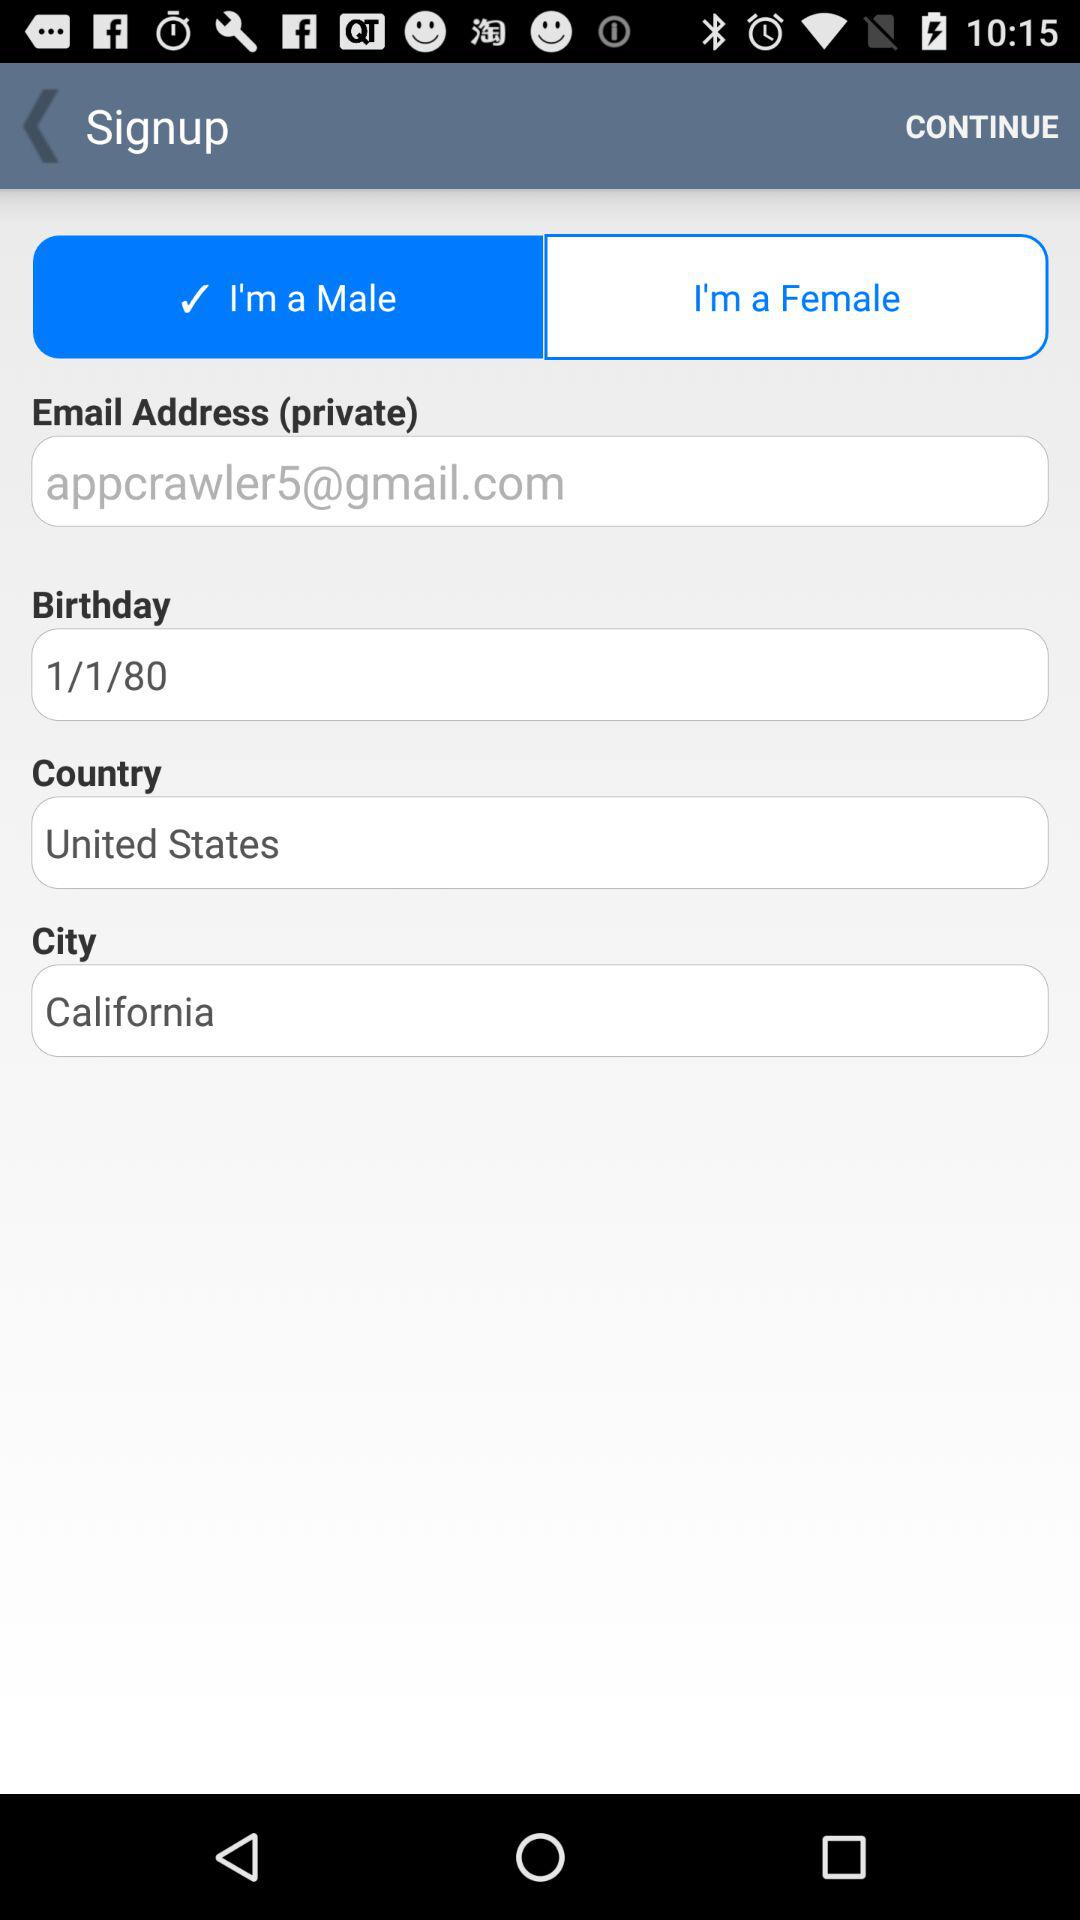What is the date of birth of the user? The date of birth of the user is January 1, 1980. 